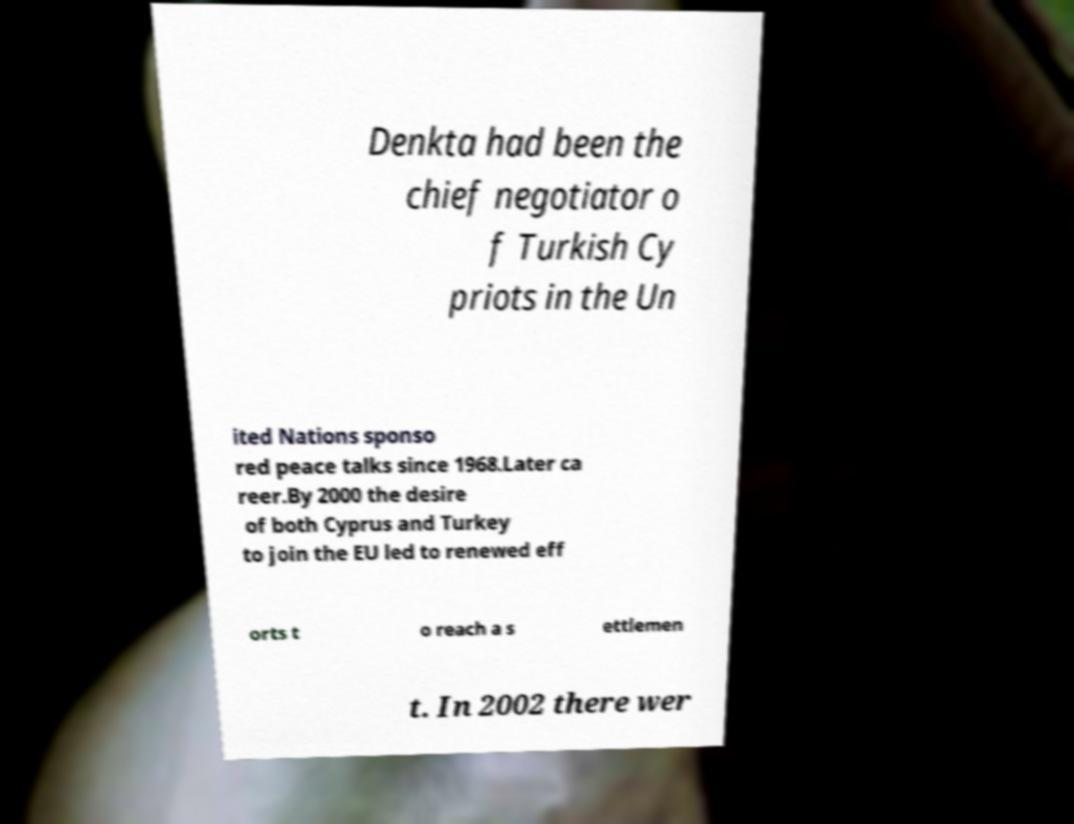Can you read and provide the text displayed in the image?This photo seems to have some interesting text. Can you extract and type it out for me? Denkta had been the chief negotiator o f Turkish Cy priots in the Un ited Nations sponso red peace talks since 1968.Later ca reer.By 2000 the desire of both Cyprus and Turkey to join the EU led to renewed eff orts t o reach a s ettlemen t. In 2002 there wer 